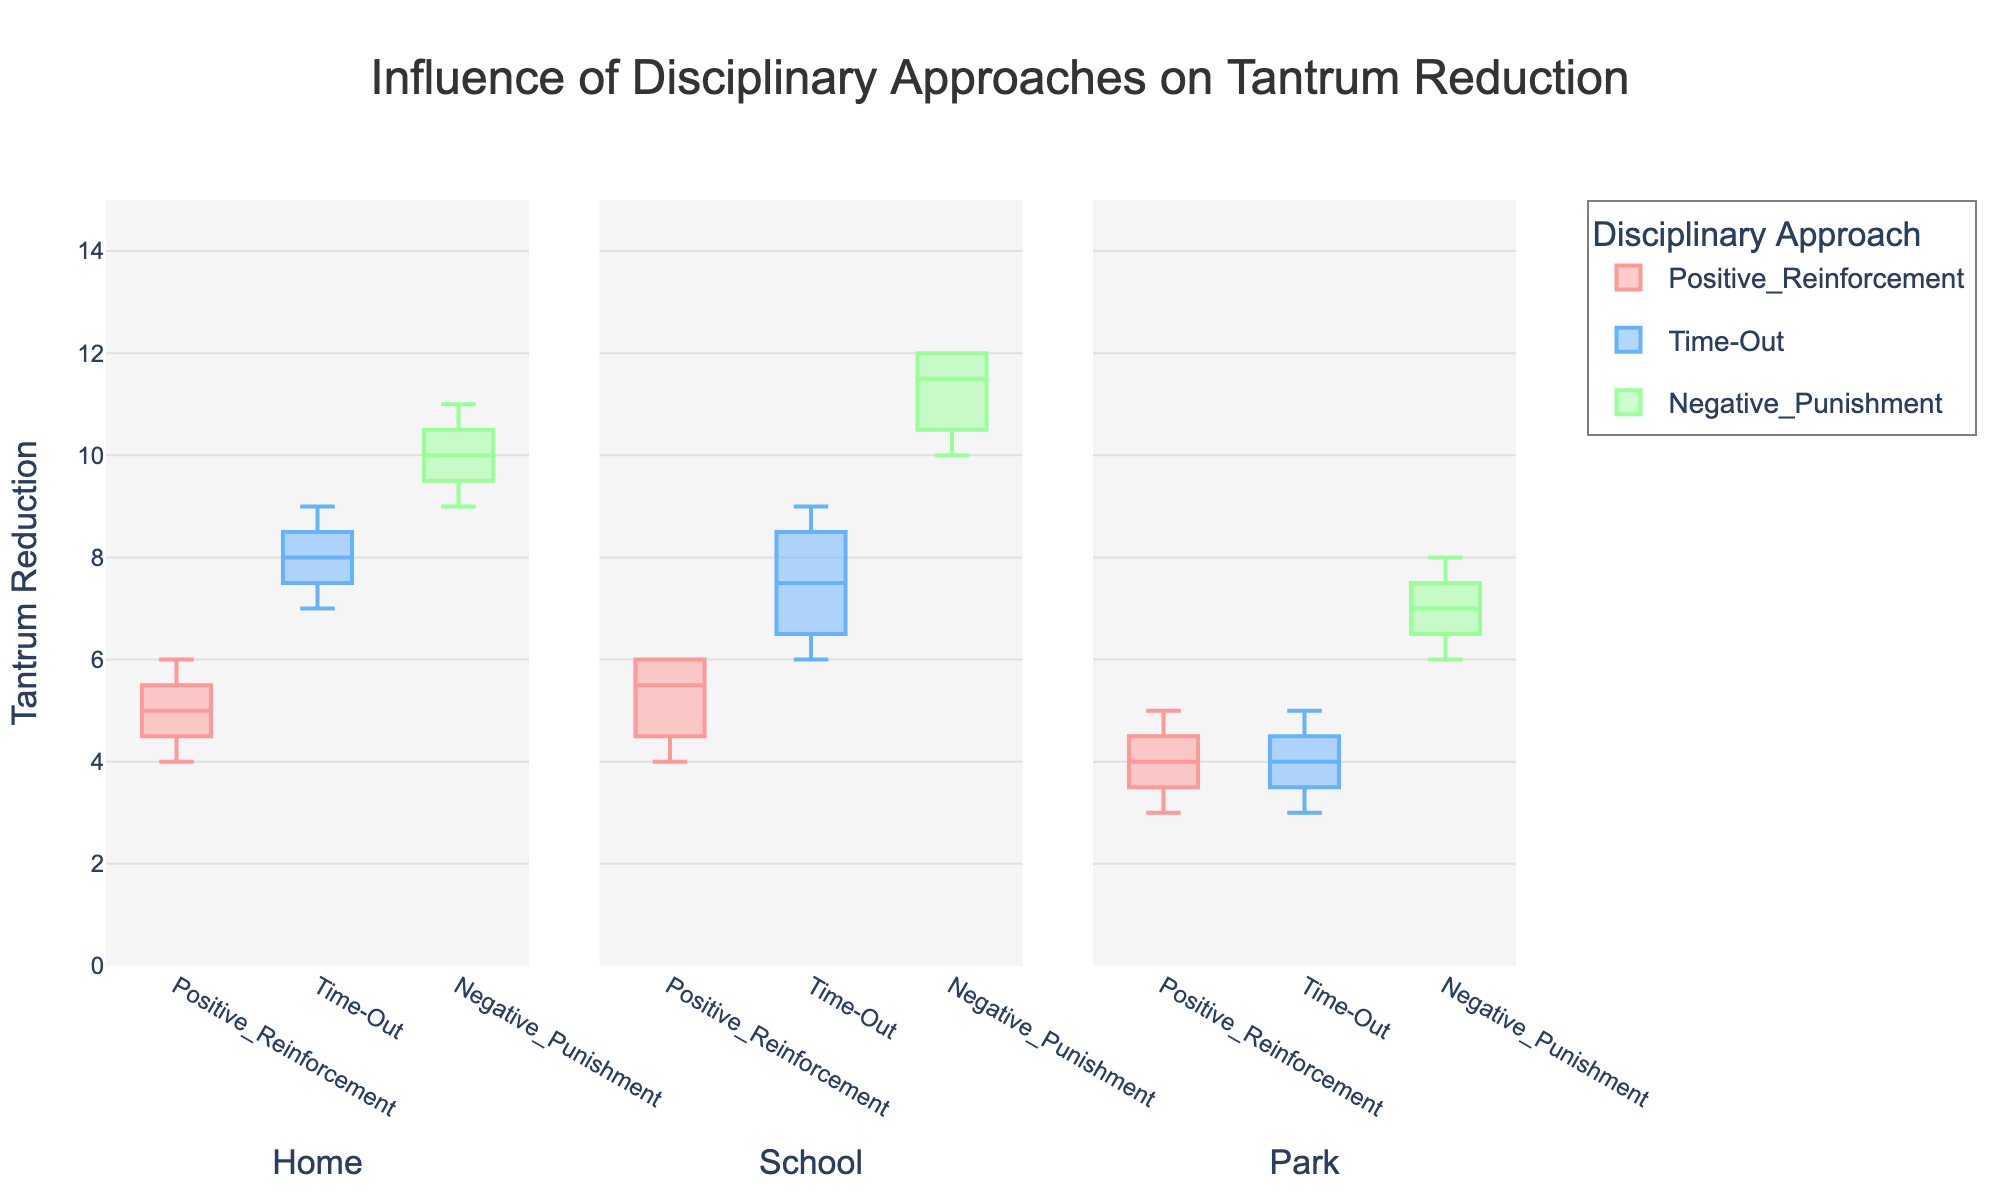What is the title of the plot? The title is typically found at the top of the figure and provides an overarching description of the plot. Here, the title summarizes what the plot is about, which is the impact of different disciplinary approaches on tantrum reduction.
Answer: Influence of Disciplinary Approaches on Tantrum Reduction What is the y-axis label, and what does it represent? The y-axis label is found along the vertical axis of the plot and indicates what measurement is being represented on this axis. In this plot, the y-axis label helps us understand that the plotted data represents the reduction in tantrum frequency.
Answer: Tantrum Reduction Which disciplinary approach appears to have the highest median reduction in tantrum frequency at home? To determine this, we look at the median line within the boxes for each disciplinary approach in the 'Home' group. The median line is the line inside the box, typically in the middle.
Answer: Negative Punishment On average, how did negative punishment perform at the park compared to time-out? To compare the performance at the park, look at the position of the box plots for 'Negative Punishment' and 'Time-Out' in the 'Park' group. Compare the range and position of these boxes.
Answer: Negative punishment shows a higher reduction on average Which environment shows the least variability in tantrum reduction with positive reinforcement? Variability can be assessed by the height of the boxes in the plots. The shorter the box, the less variability there is. We need to look at the 'Positive Reinforcement' box plots across 'Home,' 'School,' and 'Park.'
Answer: Park Which disciplinary approach demonstrates the greatest reduction in tantrum frequency at school? To answer this, compare the upper end of the box plots in the 'School' category. The approach with the highest top line in its box plot has the greatest reduction in tantrum frequency.
Answer: Negative Punishment How many data points are represented in each disciplinary approach for each environment? Count the individual points, usually represented by dots or small lines, within each box plot for one environment. This should remain consistent across all categories.
Answer: 4 Is the median tantrum reduction higher for time-out or positive reinforcement at home? Compare the median lines (central line in the boxes) for 'Time-Out' and 'Positive Reinforcement' in the 'Home' category. Determine which has a higher central line on the y-axis.
Answer: Time-Out Can you identify any outliers in the data? If so, where do they appear? Outliers would be points that lie outside the whiskers (extended lines) of the box plot. Look for any points situated significantly away from the main box and whiskers structure in any of the categories.
Answer: No, there are no outliers visibly indicated in this figure How does the interquartile range (IQR) of negative punishment compare at home and school? To evaluate this, compare the height of the boxes for 'Negative Punishment' in both the 'Home' and 'School' categories. The height of the boxes represents the IQR.
Answer: The IQR is larger at school than at home 